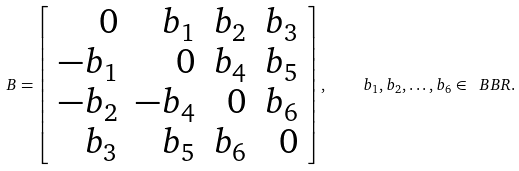Convert formula to latex. <formula><loc_0><loc_0><loc_500><loc_500>B = \left [ \begin{array} { r r r r } 0 & b _ { 1 } & b _ { 2 } & b _ { 3 } \\ - b _ { 1 } & 0 & b _ { 4 } & b _ { 5 } \\ - b _ { 2 } & - b _ { 4 } & 0 & b _ { 6 } \\ b _ { 3 } & b _ { 5 } & b _ { 6 } & 0 \end{array} \right ] , \quad b _ { 1 } , b _ { 2 } , \dots , b _ { 6 } \in \ B B { R } .</formula> 